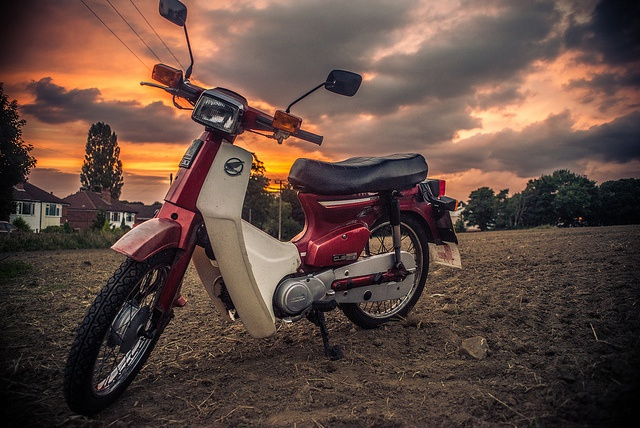Describe the objects in this image and their specific colors. I can see a motorcycle in black, gray, and maroon tones in this image. 